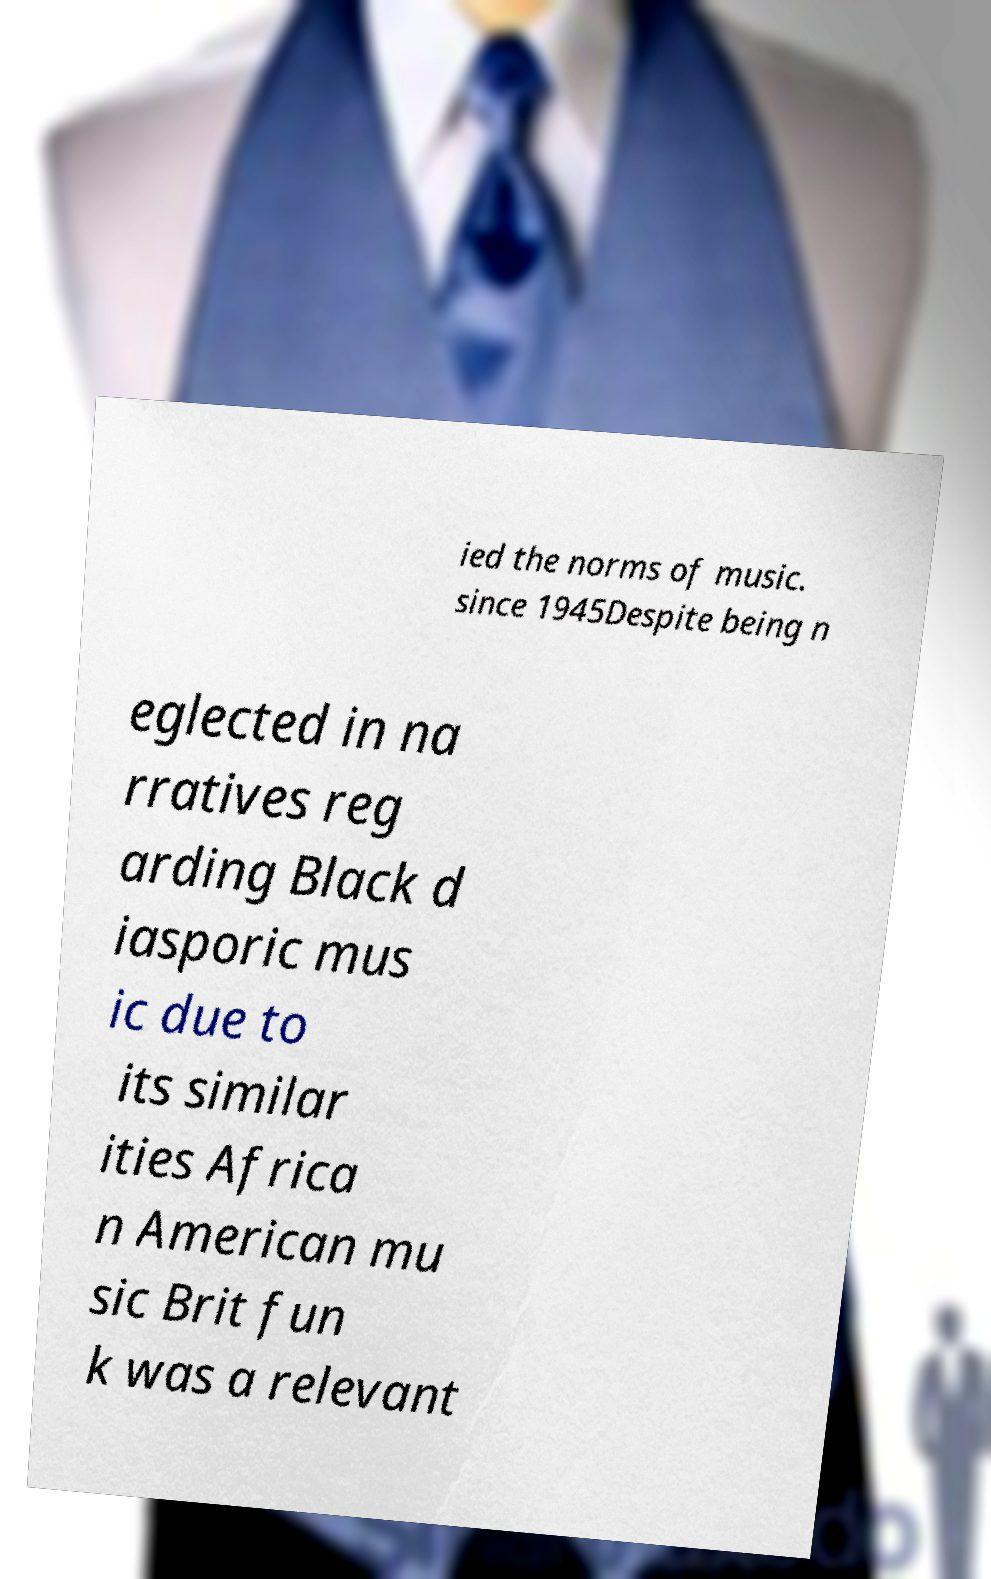For documentation purposes, I need the text within this image transcribed. Could you provide that? ied the norms of music. since 1945Despite being n eglected in na rratives reg arding Black d iasporic mus ic due to its similar ities Africa n American mu sic Brit fun k was a relevant 